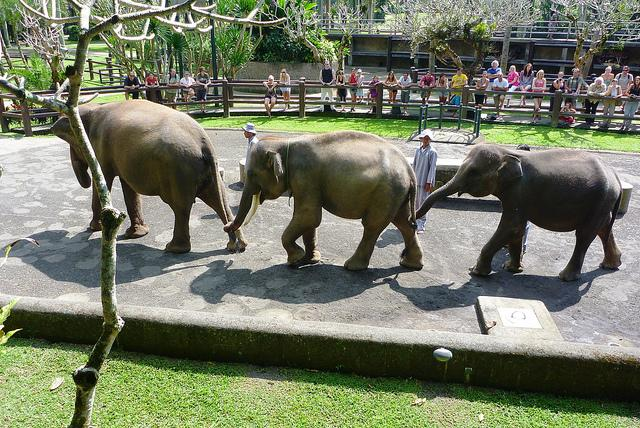What direction are the elephants marching?

Choices:
A) west
B) east
C) north
D) south west 